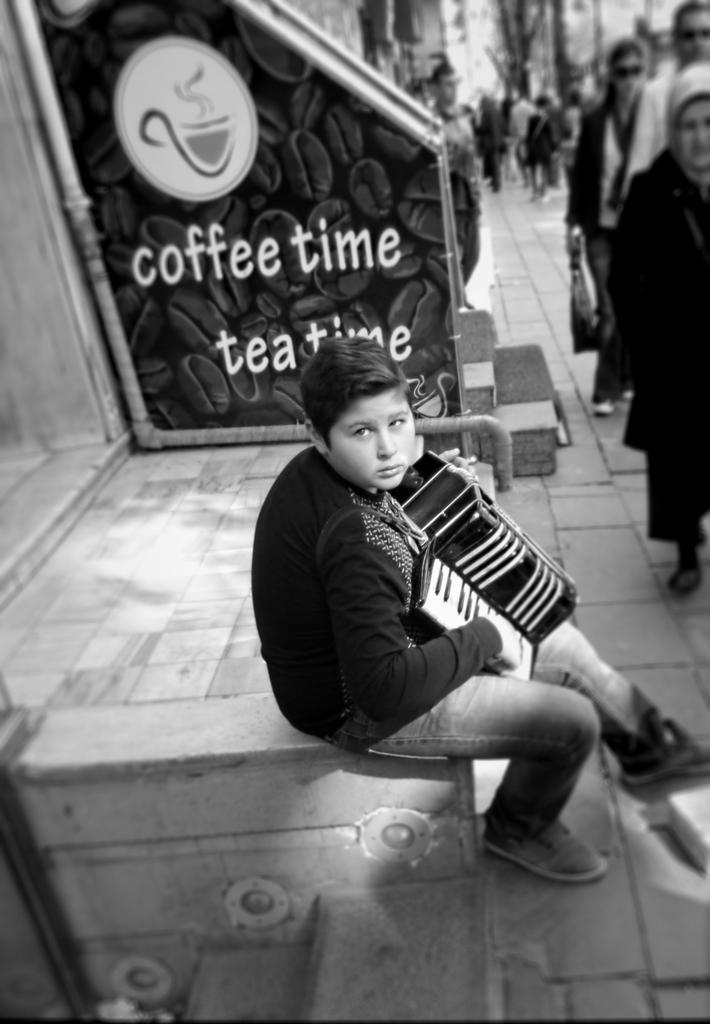In one or two sentences, can you explain what this image depicts? In this image we can see a boy playing the piano. Here we can see a few people walking on the side of the road. Here we can see the staircase on the side of the road. Here we can see the pipeline on the wall. 